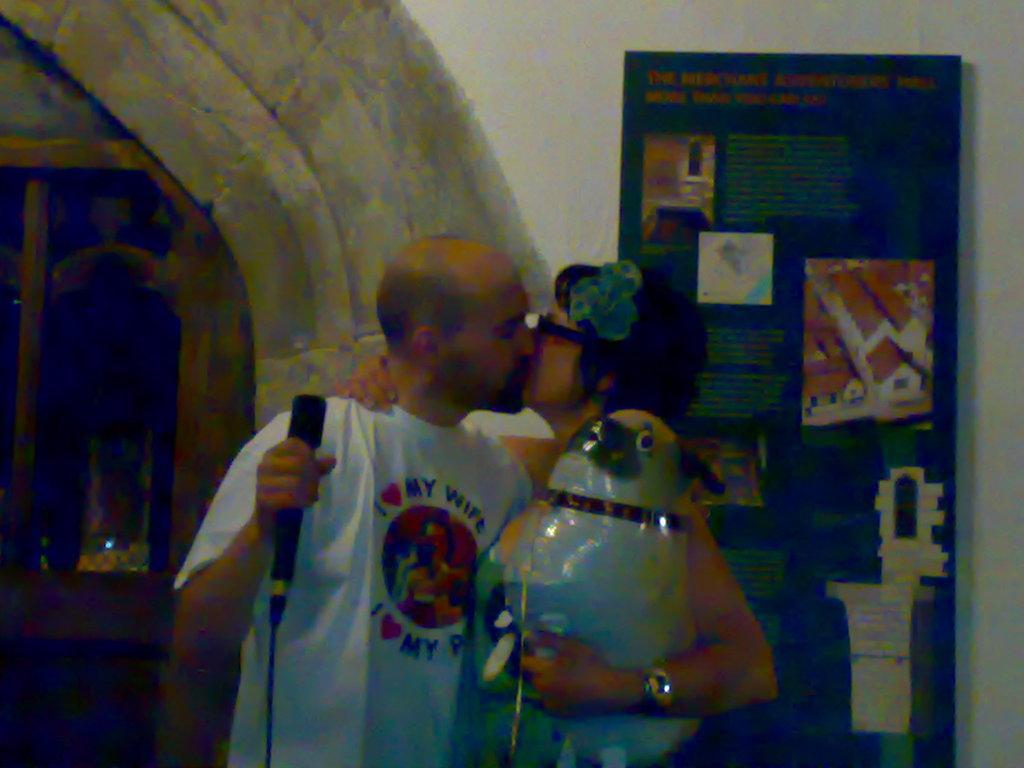Can you describe this image briefly? In this image there is a man with a mike and a woman with an object are kissing. In the background there is a window and also a board attached to the wall. 